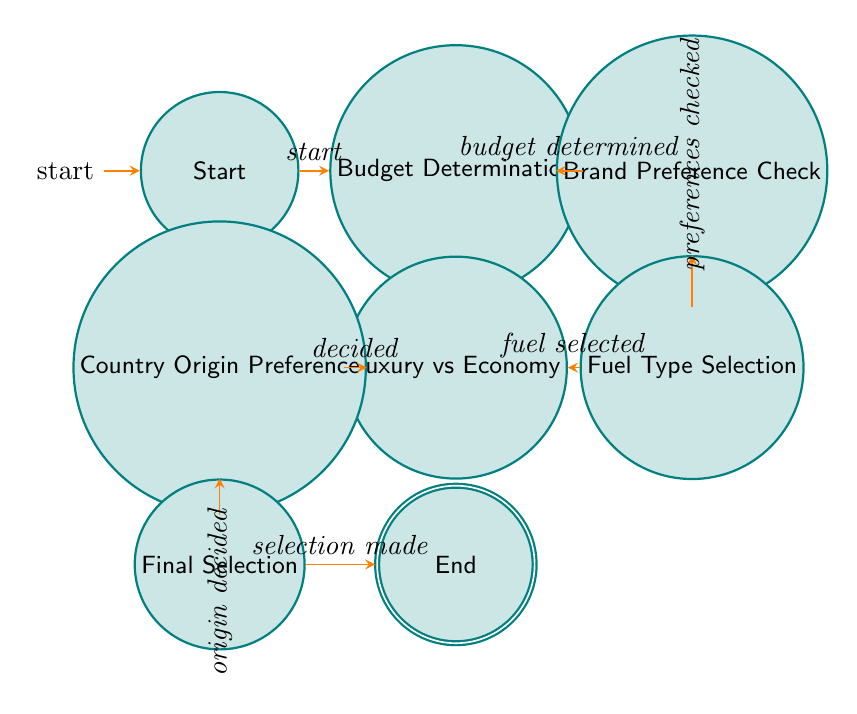What is the first state in the diagram? The first state is indicated as "Start" in the diagram. This is the initial point for the decision-making process.
Answer: Start How many nodes are there in the diagram? The diagram includes a total of 8 nodes. These nodes represent different states in the car brand selection process.
Answer: 8 What follows after "Budget Determination"? After "Budget Determination," the next state is "Brand Preference Check." This transition occurs once the budget has been determined.
Answer: Brand Preference Check Which two states are connected directly by the transition "luxury or economy decided"? The states connected by this transition are "Luxury Vs Economy" and "Country Origin Preference." This indicates a decision point between luxury and economy models leading to the next state.
Answer: Luxury Vs Economy, Country Origin Preference What is the last state in the diagram? The last state is "End," which signifies that the decision process is complete after the final selection has been made.
Answer: End What is the transition condition from "Country Origin Preference" to "Final Selection"? The transition condition is "country origin preference decided." This shows that a decision on the preferred country of origin must be made before moving to the final selection.
Answer: Country origin preference decided Which state do you reach after selecting a fuel type? After selecting a fuel type, the next state reached is "Luxury Vs Economy." This shows that the choice of fuel type leads to a decision between luxury or economy models.
Answer: Luxury Vs Economy What is the state before "Final Selection"? The state before "Final Selection" is "Country Origin Preference." This indicates that the preference for the brand's country of origin needs to be identified before making a final selection.
Answer: Country Origin Preference 